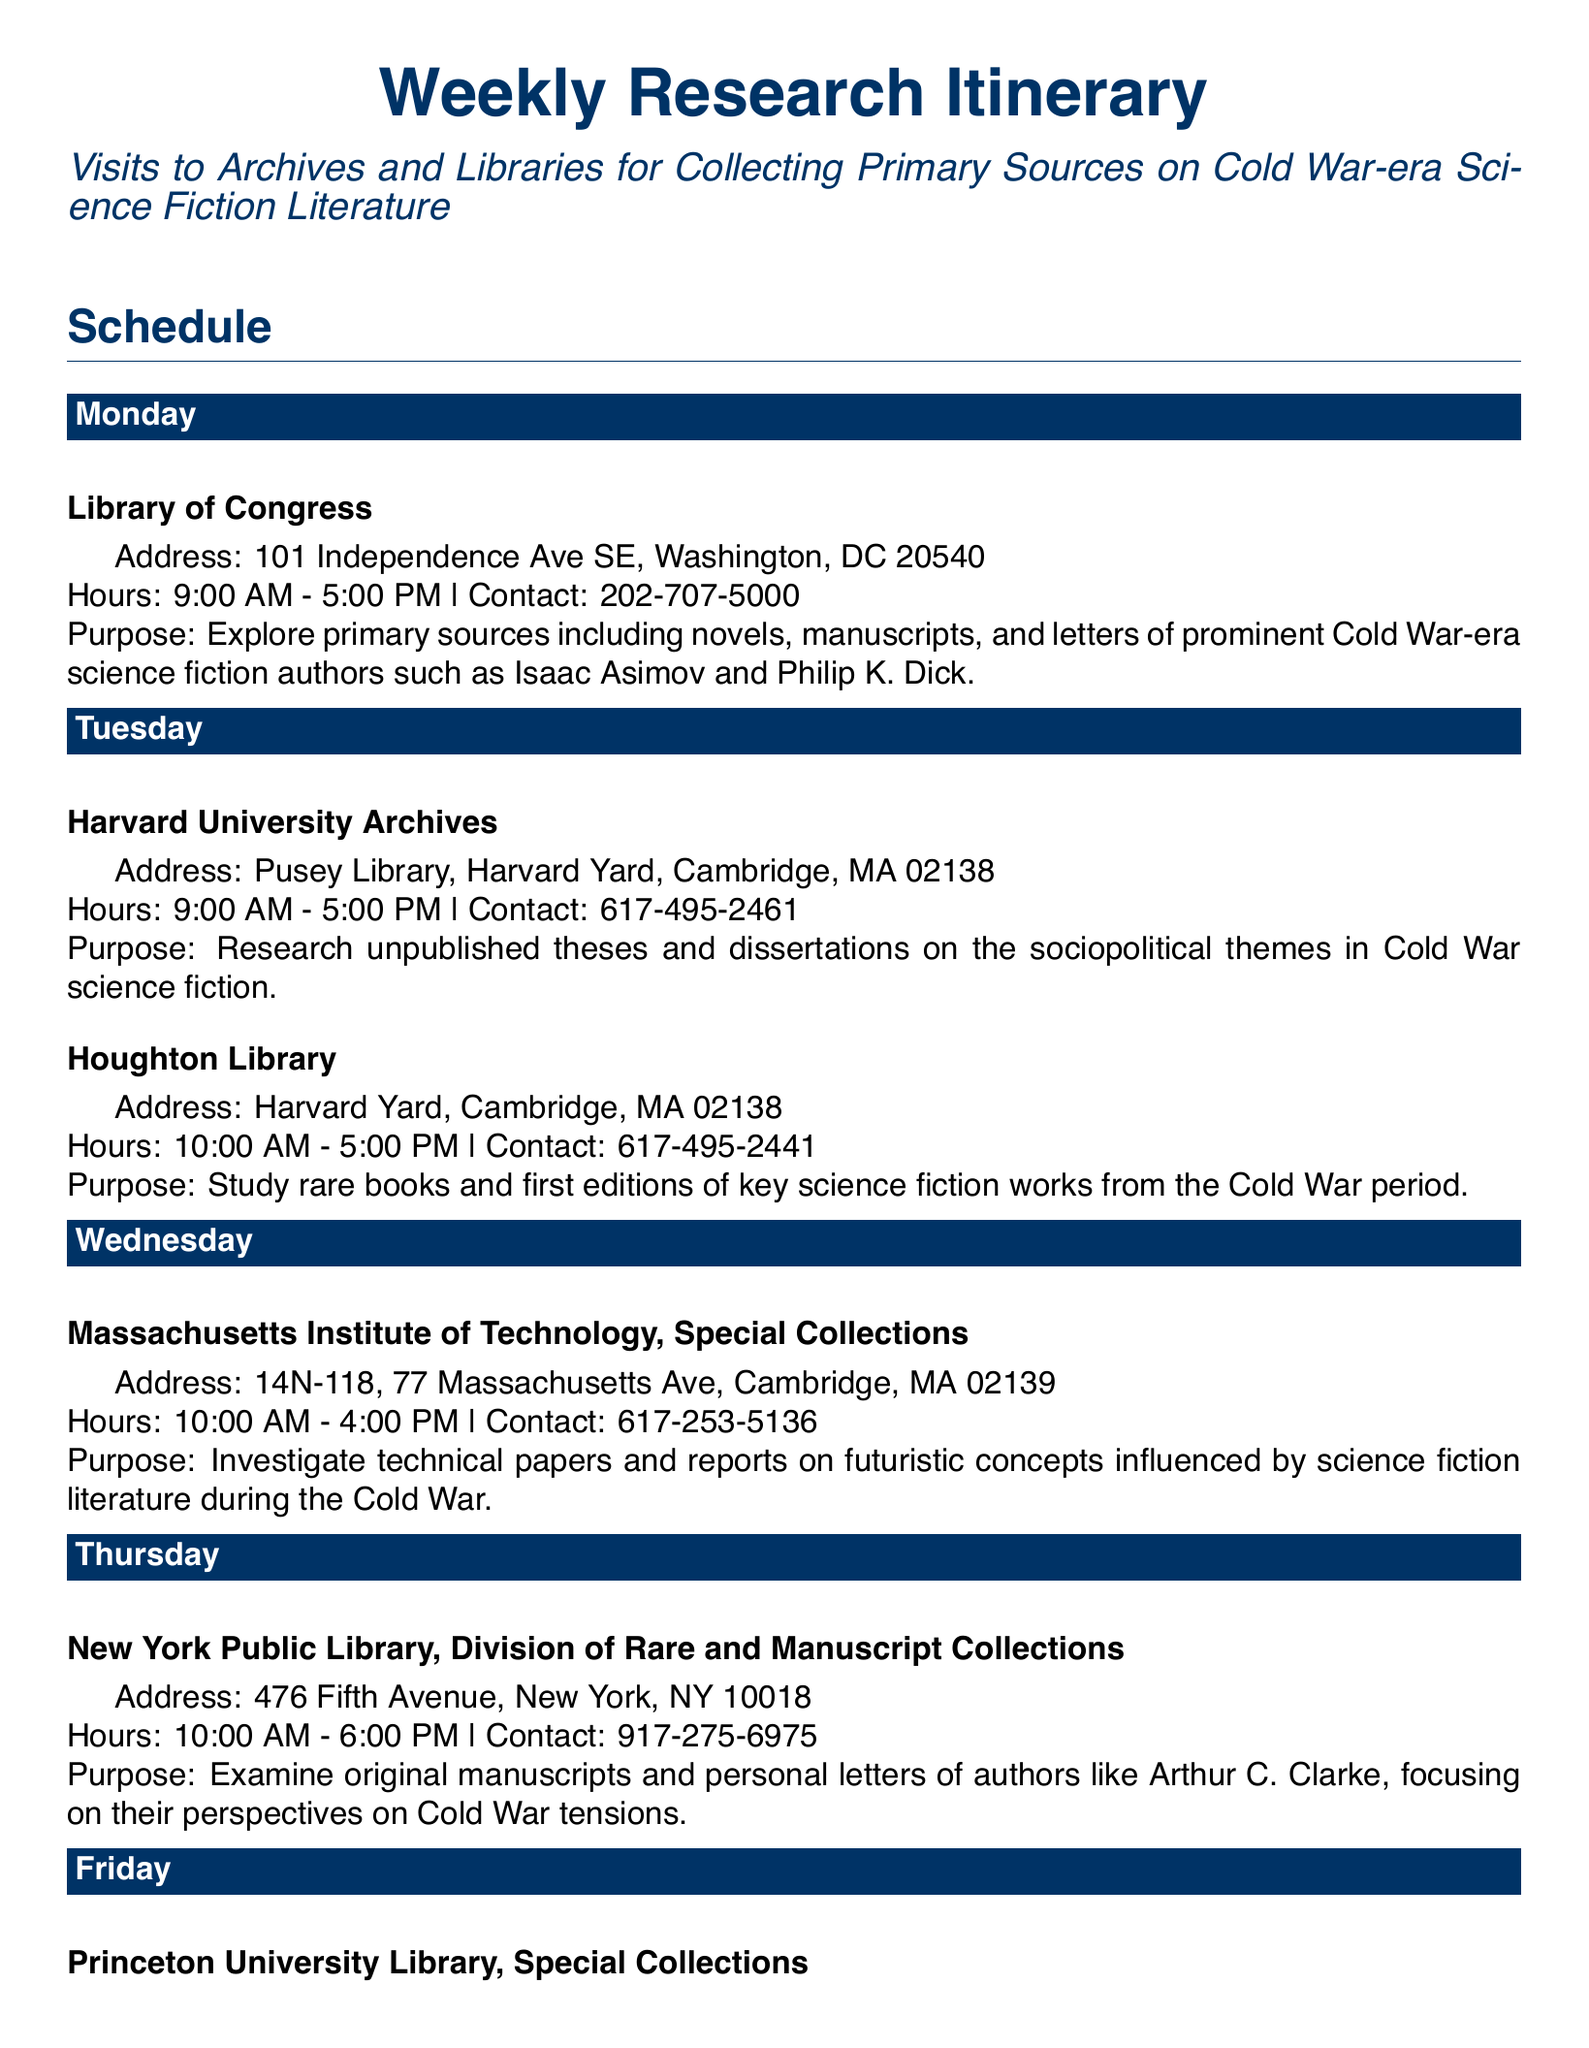What is the purpose of the visit to the Library of Congress? The purpose is to explore primary sources including novels, manuscripts, and letters of prominent Cold War-era science fiction authors.
Answer: Explore primary sources including novels, manuscripts, and letters of prominent Cold War-era science fiction authors What time does the Harvard University Archives open? The opening time is listed in the document as 9:00 AM.
Answer: 9:00 AM Which library holds original manuscripts and personal letters of authors like Arthur C. Clarke? The New York Public Library holds these materials, according to the document.
Answer: New York Public Library How many locations are visited on Tuesday? The document specifies two locations visited on Tuesday: Harvard University Archives and Houghton Library.
Answer: Two What is the address of Princeton University Library, Special Collections? The address as stated in the document is 1 Washington Rd, Princeton, NJ 08544.
Answer: 1 Washington Rd, Princeton, NJ 08544 What type of literature is reviewed at Cotsen Children's Library? The document states that the focus is on children's and young adult science fiction literature.
Answer: Children's and young adult science fiction literature What is the closing time of the New York Public Library, Division of Rare and Manuscript Collections? The closing time is listed in the document as 6:00 PM.
Answer: 6:00 PM Which primary sources are explored at the Massachusetts Institute of Technology, Special Collections? The document notes that technical papers and reports on futuristic concepts influenced by science fiction literature are investigated.
Answer: Technical papers and reports on futuristic concepts influenced by science fiction literature 